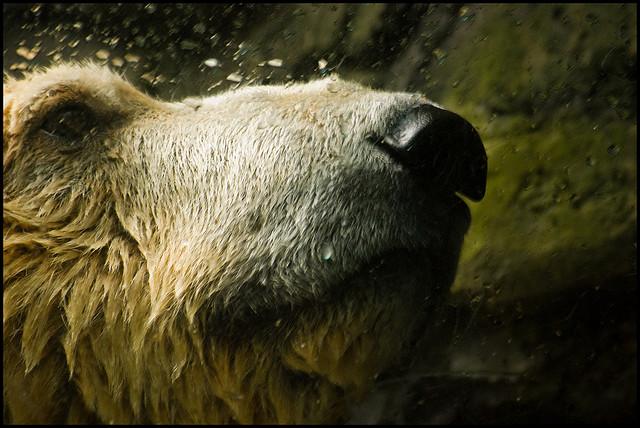What color is this bear?
Be succinct. White. Is this a close up shot?
Give a very brief answer. Yes. What is this animal?
Write a very short answer. Bear. Does it appear to be raining?
Concise answer only. Yes. What portion of the bear is visible?
Give a very brief answer. Face. 